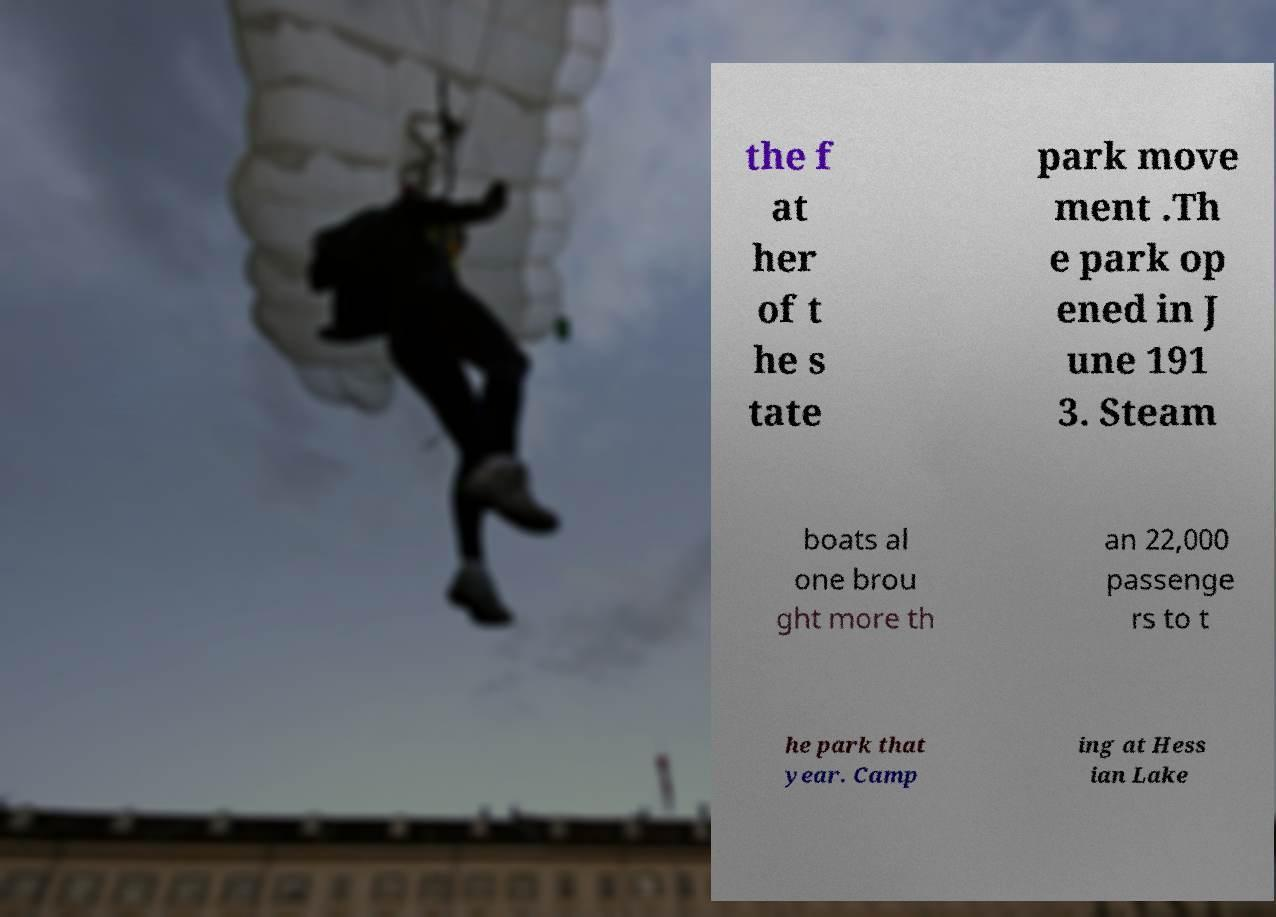Please read and relay the text visible in this image. What does it say? the f at her of t he s tate park move ment .Th e park op ened in J une 191 3. Steam boats al one brou ght more th an 22,000 passenge rs to t he park that year. Camp ing at Hess ian Lake 